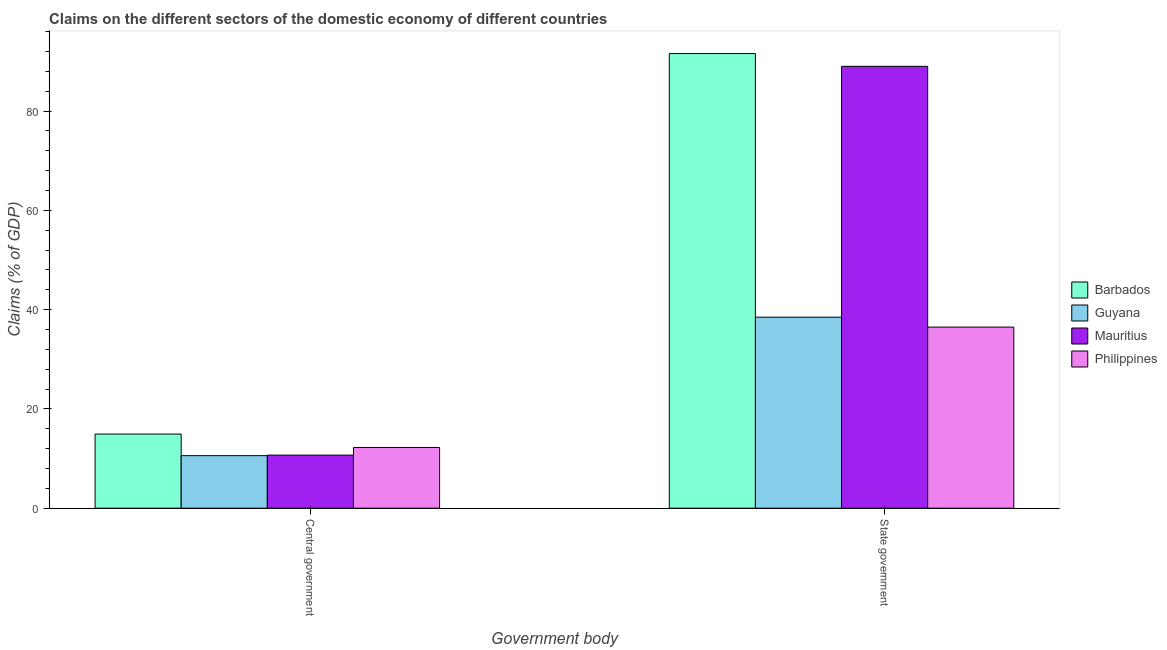How many groups of bars are there?
Keep it short and to the point. 2. Are the number of bars per tick equal to the number of legend labels?
Your answer should be very brief. Yes. How many bars are there on the 2nd tick from the right?
Provide a short and direct response. 4. What is the label of the 2nd group of bars from the left?
Your answer should be very brief. State government. What is the claims on central government in Mauritius?
Keep it short and to the point. 10.69. Across all countries, what is the maximum claims on central government?
Your response must be concise. 14.93. Across all countries, what is the minimum claims on state government?
Your answer should be very brief. 36.48. In which country was the claims on central government maximum?
Your answer should be very brief. Barbados. In which country was the claims on central government minimum?
Ensure brevity in your answer.  Guyana. What is the total claims on state government in the graph?
Provide a short and direct response. 255.55. What is the difference between the claims on central government in Philippines and that in Guyana?
Your answer should be very brief. 1.65. What is the difference between the claims on central government in Barbados and the claims on state government in Guyana?
Keep it short and to the point. -23.55. What is the average claims on central government per country?
Keep it short and to the point. 12.11. What is the difference between the claims on state government and claims on central government in Philippines?
Offer a terse response. 24.25. In how many countries, is the claims on central government greater than 64 %?
Your answer should be compact. 0. What is the ratio of the claims on state government in Guyana to that in Barbados?
Keep it short and to the point. 0.42. Is the claims on state government in Mauritius less than that in Philippines?
Your answer should be compact. No. What does the 1st bar from the right in State government represents?
Provide a succinct answer. Philippines. Does the graph contain any zero values?
Your answer should be very brief. No. Where does the legend appear in the graph?
Provide a short and direct response. Center right. How are the legend labels stacked?
Your response must be concise. Vertical. What is the title of the graph?
Provide a short and direct response. Claims on the different sectors of the domestic economy of different countries. What is the label or title of the X-axis?
Provide a succinct answer. Government body. What is the label or title of the Y-axis?
Ensure brevity in your answer.  Claims (% of GDP). What is the Claims (% of GDP) in Barbados in Central government?
Your answer should be very brief. 14.93. What is the Claims (% of GDP) of Guyana in Central government?
Provide a short and direct response. 10.58. What is the Claims (% of GDP) of Mauritius in Central government?
Provide a short and direct response. 10.69. What is the Claims (% of GDP) in Philippines in Central government?
Give a very brief answer. 12.23. What is the Claims (% of GDP) of Barbados in State government?
Provide a short and direct response. 91.58. What is the Claims (% of GDP) of Guyana in State government?
Your answer should be very brief. 38.48. What is the Claims (% of GDP) in Mauritius in State government?
Your response must be concise. 89.01. What is the Claims (% of GDP) in Philippines in State government?
Your answer should be compact. 36.48. Across all Government body, what is the maximum Claims (% of GDP) of Barbados?
Keep it short and to the point. 91.58. Across all Government body, what is the maximum Claims (% of GDP) of Guyana?
Provide a succinct answer. 38.48. Across all Government body, what is the maximum Claims (% of GDP) of Mauritius?
Keep it short and to the point. 89.01. Across all Government body, what is the maximum Claims (% of GDP) in Philippines?
Offer a very short reply. 36.48. Across all Government body, what is the minimum Claims (% of GDP) in Barbados?
Ensure brevity in your answer.  14.93. Across all Government body, what is the minimum Claims (% of GDP) in Guyana?
Give a very brief answer. 10.58. Across all Government body, what is the minimum Claims (% of GDP) of Mauritius?
Your response must be concise. 10.69. Across all Government body, what is the minimum Claims (% of GDP) in Philippines?
Your response must be concise. 12.23. What is the total Claims (% of GDP) of Barbados in the graph?
Make the answer very short. 106.52. What is the total Claims (% of GDP) of Guyana in the graph?
Ensure brevity in your answer.  49.06. What is the total Claims (% of GDP) in Mauritius in the graph?
Keep it short and to the point. 99.7. What is the total Claims (% of GDP) of Philippines in the graph?
Ensure brevity in your answer.  48.72. What is the difference between the Claims (% of GDP) in Barbados in Central government and that in State government?
Your answer should be compact. -76.65. What is the difference between the Claims (% of GDP) in Guyana in Central government and that in State government?
Provide a short and direct response. -27.9. What is the difference between the Claims (% of GDP) of Mauritius in Central government and that in State government?
Ensure brevity in your answer.  -78.32. What is the difference between the Claims (% of GDP) of Philippines in Central government and that in State government?
Provide a succinct answer. -24.25. What is the difference between the Claims (% of GDP) of Barbados in Central government and the Claims (% of GDP) of Guyana in State government?
Provide a succinct answer. -23.55. What is the difference between the Claims (% of GDP) of Barbados in Central government and the Claims (% of GDP) of Mauritius in State government?
Your response must be concise. -74.08. What is the difference between the Claims (% of GDP) of Barbados in Central government and the Claims (% of GDP) of Philippines in State government?
Provide a succinct answer. -21.55. What is the difference between the Claims (% of GDP) in Guyana in Central government and the Claims (% of GDP) in Mauritius in State government?
Provide a succinct answer. -78.43. What is the difference between the Claims (% of GDP) in Guyana in Central government and the Claims (% of GDP) in Philippines in State government?
Provide a succinct answer. -25.9. What is the difference between the Claims (% of GDP) in Mauritius in Central government and the Claims (% of GDP) in Philippines in State government?
Provide a short and direct response. -25.79. What is the average Claims (% of GDP) of Barbados per Government body?
Ensure brevity in your answer.  53.26. What is the average Claims (% of GDP) in Guyana per Government body?
Keep it short and to the point. 24.53. What is the average Claims (% of GDP) in Mauritius per Government body?
Offer a very short reply. 49.85. What is the average Claims (% of GDP) of Philippines per Government body?
Keep it short and to the point. 24.36. What is the difference between the Claims (% of GDP) in Barbados and Claims (% of GDP) in Guyana in Central government?
Your answer should be compact. 4.35. What is the difference between the Claims (% of GDP) in Barbados and Claims (% of GDP) in Mauritius in Central government?
Your answer should be very brief. 4.24. What is the difference between the Claims (% of GDP) in Barbados and Claims (% of GDP) in Philippines in Central government?
Your response must be concise. 2.7. What is the difference between the Claims (% of GDP) of Guyana and Claims (% of GDP) of Mauritius in Central government?
Provide a short and direct response. -0.11. What is the difference between the Claims (% of GDP) in Guyana and Claims (% of GDP) in Philippines in Central government?
Offer a very short reply. -1.65. What is the difference between the Claims (% of GDP) of Mauritius and Claims (% of GDP) of Philippines in Central government?
Keep it short and to the point. -1.54. What is the difference between the Claims (% of GDP) in Barbados and Claims (% of GDP) in Guyana in State government?
Offer a terse response. 53.11. What is the difference between the Claims (% of GDP) of Barbados and Claims (% of GDP) of Mauritius in State government?
Your answer should be compact. 2.57. What is the difference between the Claims (% of GDP) in Barbados and Claims (% of GDP) in Philippines in State government?
Ensure brevity in your answer.  55.1. What is the difference between the Claims (% of GDP) of Guyana and Claims (% of GDP) of Mauritius in State government?
Offer a terse response. -50.53. What is the difference between the Claims (% of GDP) of Guyana and Claims (% of GDP) of Philippines in State government?
Ensure brevity in your answer.  1.99. What is the difference between the Claims (% of GDP) of Mauritius and Claims (% of GDP) of Philippines in State government?
Give a very brief answer. 52.53. What is the ratio of the Claims (% of GDP) of Barbados in Central government to that in State government?
Make the answer very short. 0.16. What is the ratio of the Claims (% of GDP) of Guyana in Central government to that in State government?
Keep it short and to the point. 0.28. What is the ratio of the Claims (% of GDP) in Mauritius in Central government to that in State government?
Make the answer very short. 0.12. What is the ratio of the Claims (% of GDP) of Philippines in Central government to that in State government?
Provide a succinct answer. 0.34. What is the difference between the highest and the second highest Claims (% of GDP) of Barbados?
Give a very brief answer. 76.65. What is the difference between the highest and the second highest Claims (% of GDP) in Guyana?
Offer a terse response. 27.9. What is the difference between the highest and the second highest Claims (% of GDP) in Mauritius?
Give a very brief answer. 78.32. What is the difference between the highest and the second highest Claims (% of GDP) of Philippines?
Give a very brief answer. 24.25. What is the difference between the highest and the lowest Claims (% of GDP) in Barbados?
Keep it short and to the point. 76.65. What is the difference between the highest and the lowest Claims (% of GDP) in Guyana?
Give a very brief answer. 27.9. What is the difference between the highest and the lowest Claims (% of GDP) of Mauritius?
Offer a terse response. 78.32. What is the difference between the highest and the lowest Claims (% of GDP) in Philippines?
Keep it short and to the point. 24.25. 